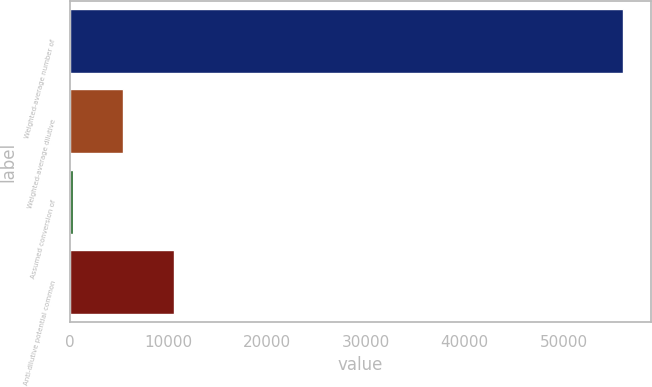Convert chart. <chart><loc_0><loc_0><loc_500><loc_500><bar_chart><fcel>Weighted-average number of<fcel>Weighted-average dilutive<fcel>Assumed conversion of<fcel>Anti-dilutive potential common<nl><fcel>56073.5<fcel>5391.5<fcel>258<fcel>10525<nl></chart> 